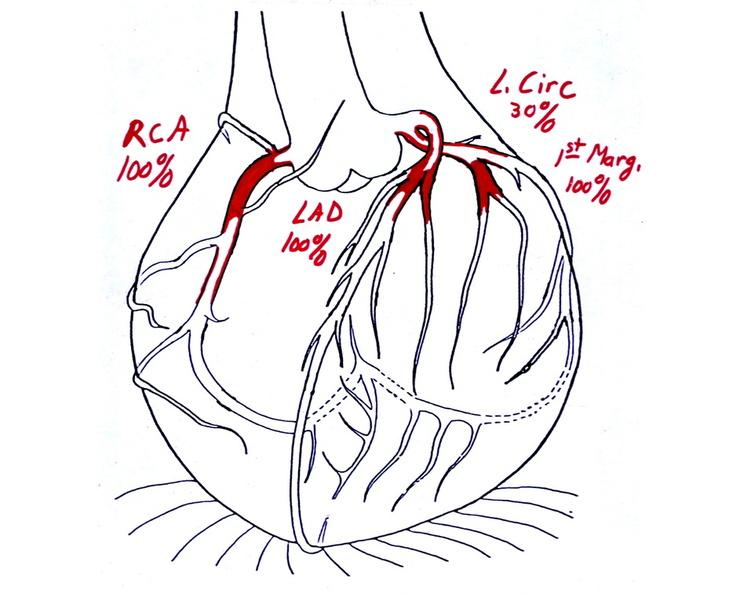s acute peritonitis present?
Answer the question using a single word or phrase. No 